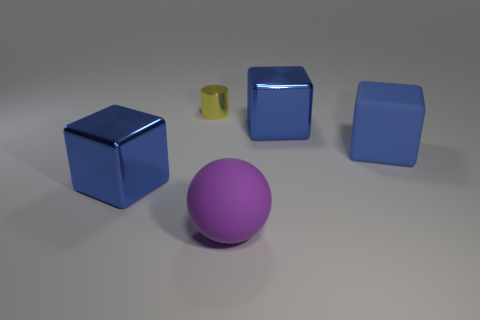Add 1 large things. How many objects exist? 6 Subtract all metal cubes. How many cubes are left? 1 Add 5 big matte things. How many big matte things are left? 7 Add 1 small yellow things. How many small yellow things exist? 2 Subtract 0 brown blocks. How many objects are left? 5 Subtract all cylinders. How many objects are left? 4 Subtract 3 cubes. How many cubes are left? 0 Subtract all red balls. Subtract all blue cylinders. How many balls are left? 1 Subtract all big purple balls. Subtract all metallic cylinders. How many objects are left? 3 